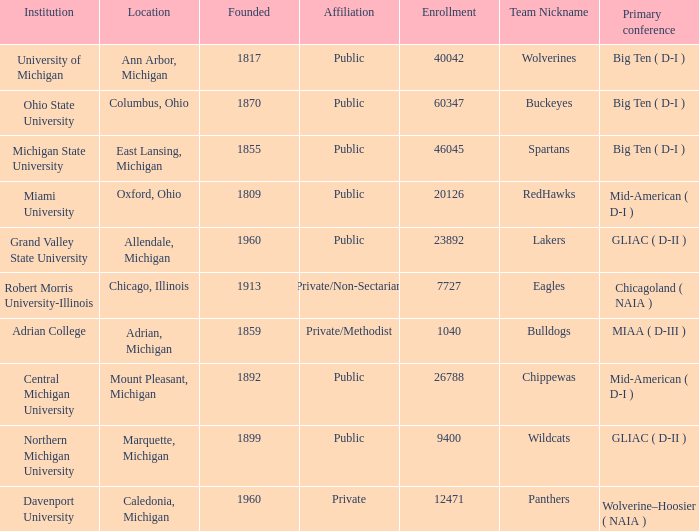What is the nickname of the Adrian, Michigan team? Bulldogs. 